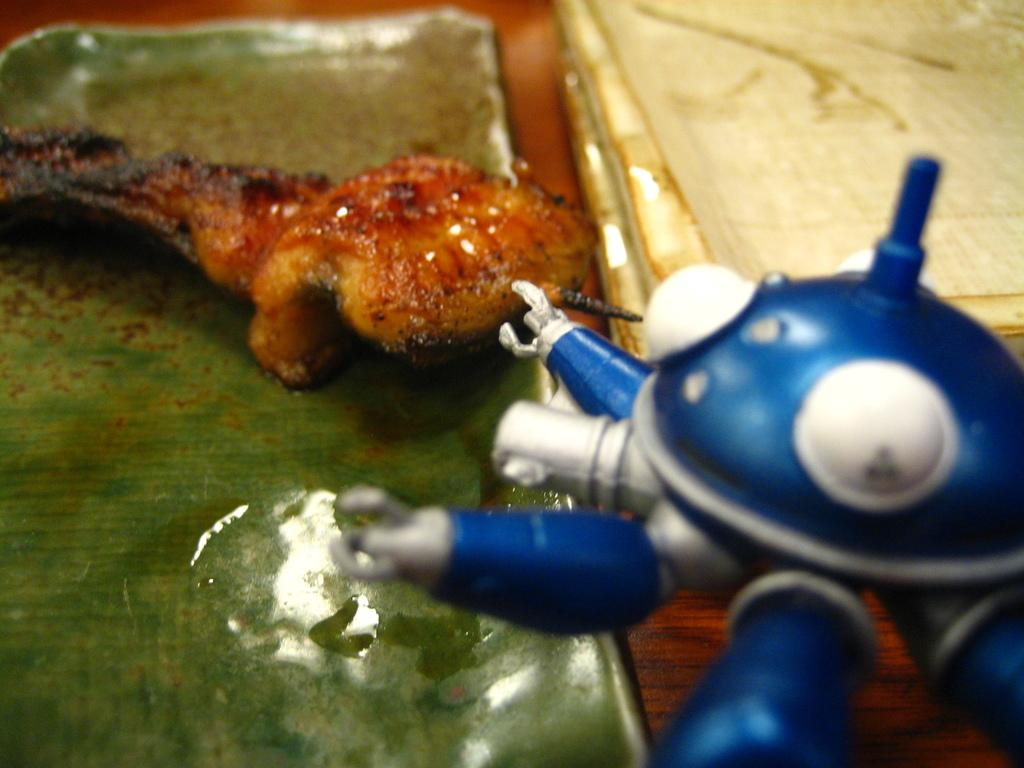What is the food placed on in the image? The food is placed on a leaf in the image. What other object can be seen in the image besides the food? There is a toy in the image. What color are the objects on the right side of the image? The objects on the right side of the image are white. What type of prison can be seen in the image? There is no prison present in the image. What kind of guide is depicted in the image? There is no guide depicted in the image. 